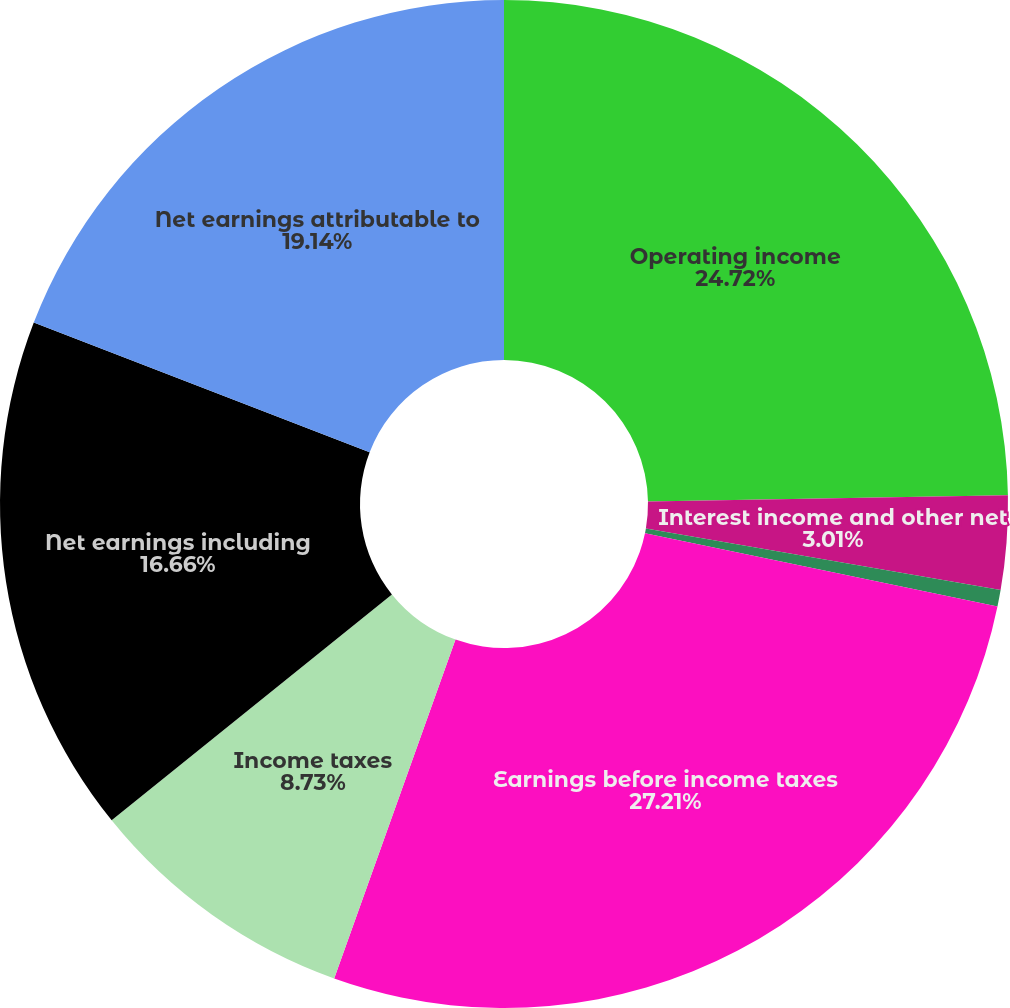Convert chart to OTSL. <chart><loc_0><loc_0><loc_500><loc_500><pie_chart><fcel>Operating income<fcel>Interest income and other net<fcel>Interest expense<fcel>Earnings before income taxes<fcel>Income taxes<fcel>Net earnings including<fcel>Net earnings attributable to<nl><fcel>24.72%<fcel>3.01%<fcel>0.53%<fcel>27.21%<fcel>8.73%<fcel>16.66%<fcel>19.14%<nl></chart> 